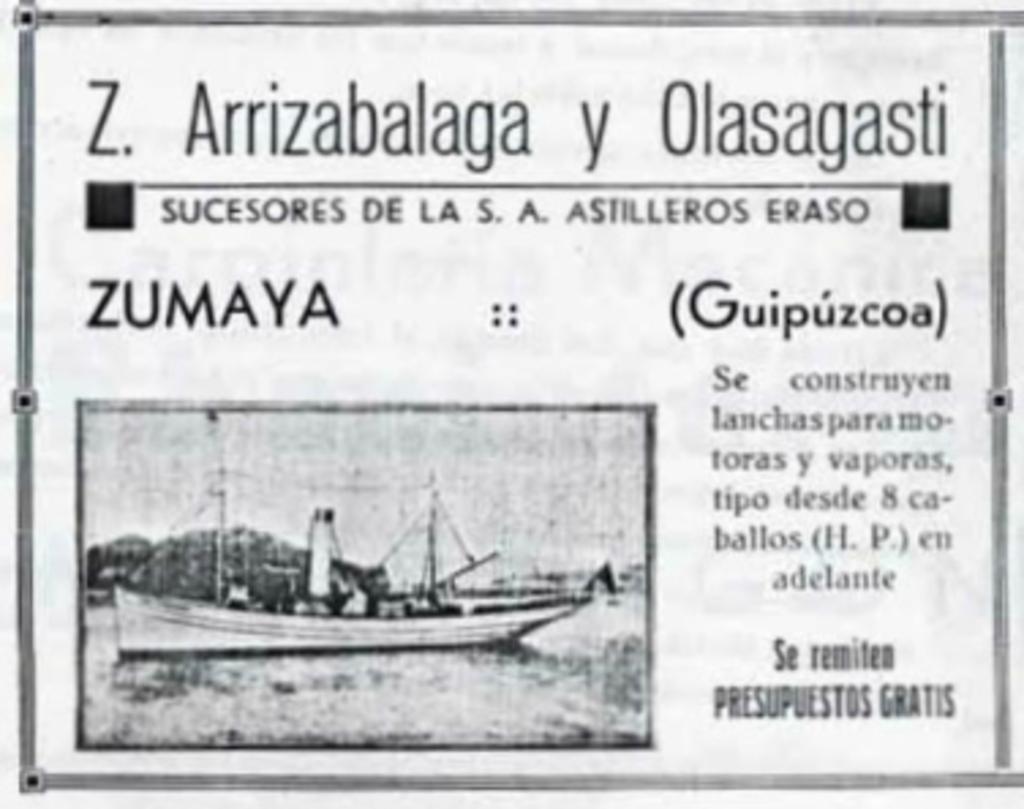How would you summarize this image in a sentence or two? In this image we can see a black and white picture of a ship in a water body. We can also see some text on this image. 